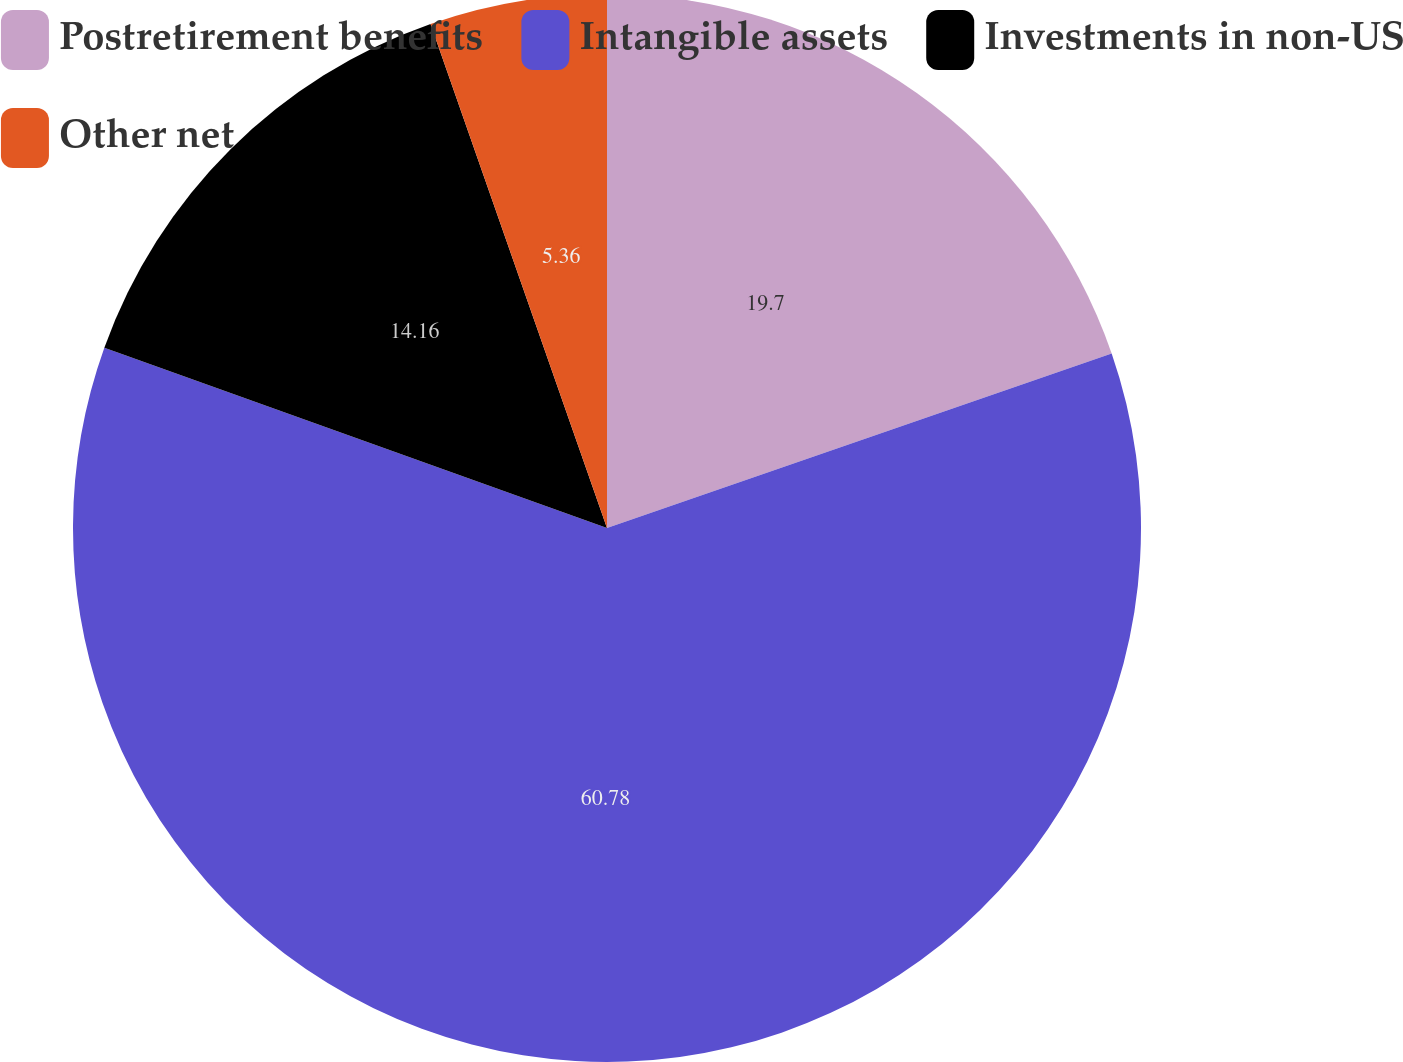<chart> <loc_0><loc_0><loc_500><loc_500><pie_chart><fcel>Postretirement benefits<fcel>Intangible assets<fcel>Investments in non-US<fcel>Other net<nl><fcel>19.7%<fcel>60.78%<fcel>14.16%<fcel>5.36%<nl></chart> 